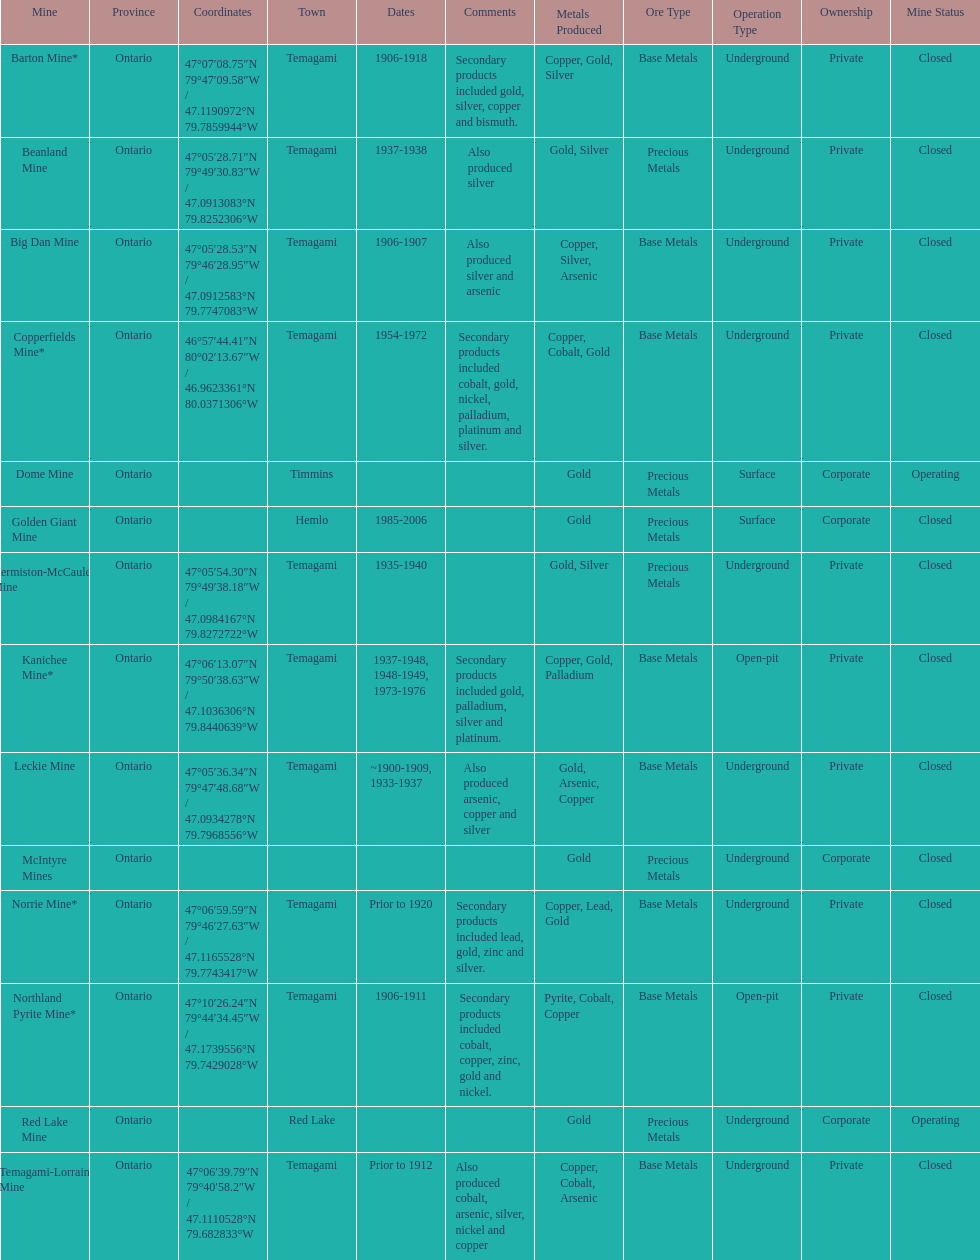How many times is temagami listedon the list? 10. 